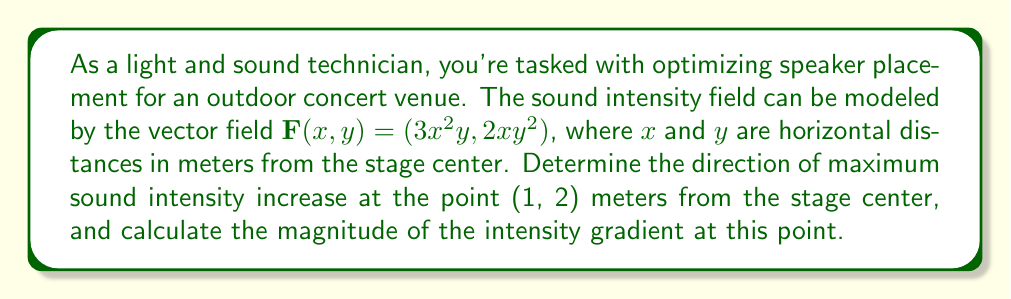Solve this math problem. To solve this problem, we need to use the concept of gradients in vector fields. The gradient of a vector field gives the direction of steepest increase and its magnitude at any point.

1) First, we need to calculate the gradient of the vector field $\mathbf{F}(x,y) = (3x^2y, 2xy^2)$. The gradient is given by:

   $$\nabla \mathbf{F} = \left(\frac{\partial F_x}{\partial x}, \frac{\partial F_y}{\partial y}\right)$$

2) Calculate the partial derivatives:
   
   $\frac{\partial F_x}{\partial x} = 6xy$
   $\frac{\partial F_y}{\partial y} = 4xy$

3) Therefore, the gradient is:

   $$\nabla \mathbf{F} = (6xy, 4xy)$$

4) At the point (1, 2), we can evaluate the gradient:

   $$\nabla \mathbf{F}(1,2) = (6(1)(2), 4(1)(2)) = (12, 8)$$

5) The direction of maximum increase is given by the gradient vector $(12, 8)$.

6) To find the unit vector in this direction, we normalize the gradient:

   $$\frac{(12, 8)}{\sqrt{12^2 + 8^2}} = \frac{(12, 8)}{\sqrt{208}} = \left(\frac{3\sqrt{13}}{13}, \frac{2\sqrt{13}}{13}\right)$$

7) The magnitude of the gradient at (1, 2) is:

   $$\|\nabla \mathbf{F}(1,2)\| = \sqrt{12^2 + 8^2} = \sqrt{208} = 4\sqrt{13}$$

This magnitude represents the rate of change of sound intensity in the direction of steepest increase.
Answer: The direction of maximum sound intensity increase at (1, 2) meters from the stage center is $\left(\frac{3\sqrt{13}}{13}, \frac{2\sqrt{13}}{13}\right)$, and the magnitude of the intensity gradient at this point is $4\sqrt{13}$ units per meter. 